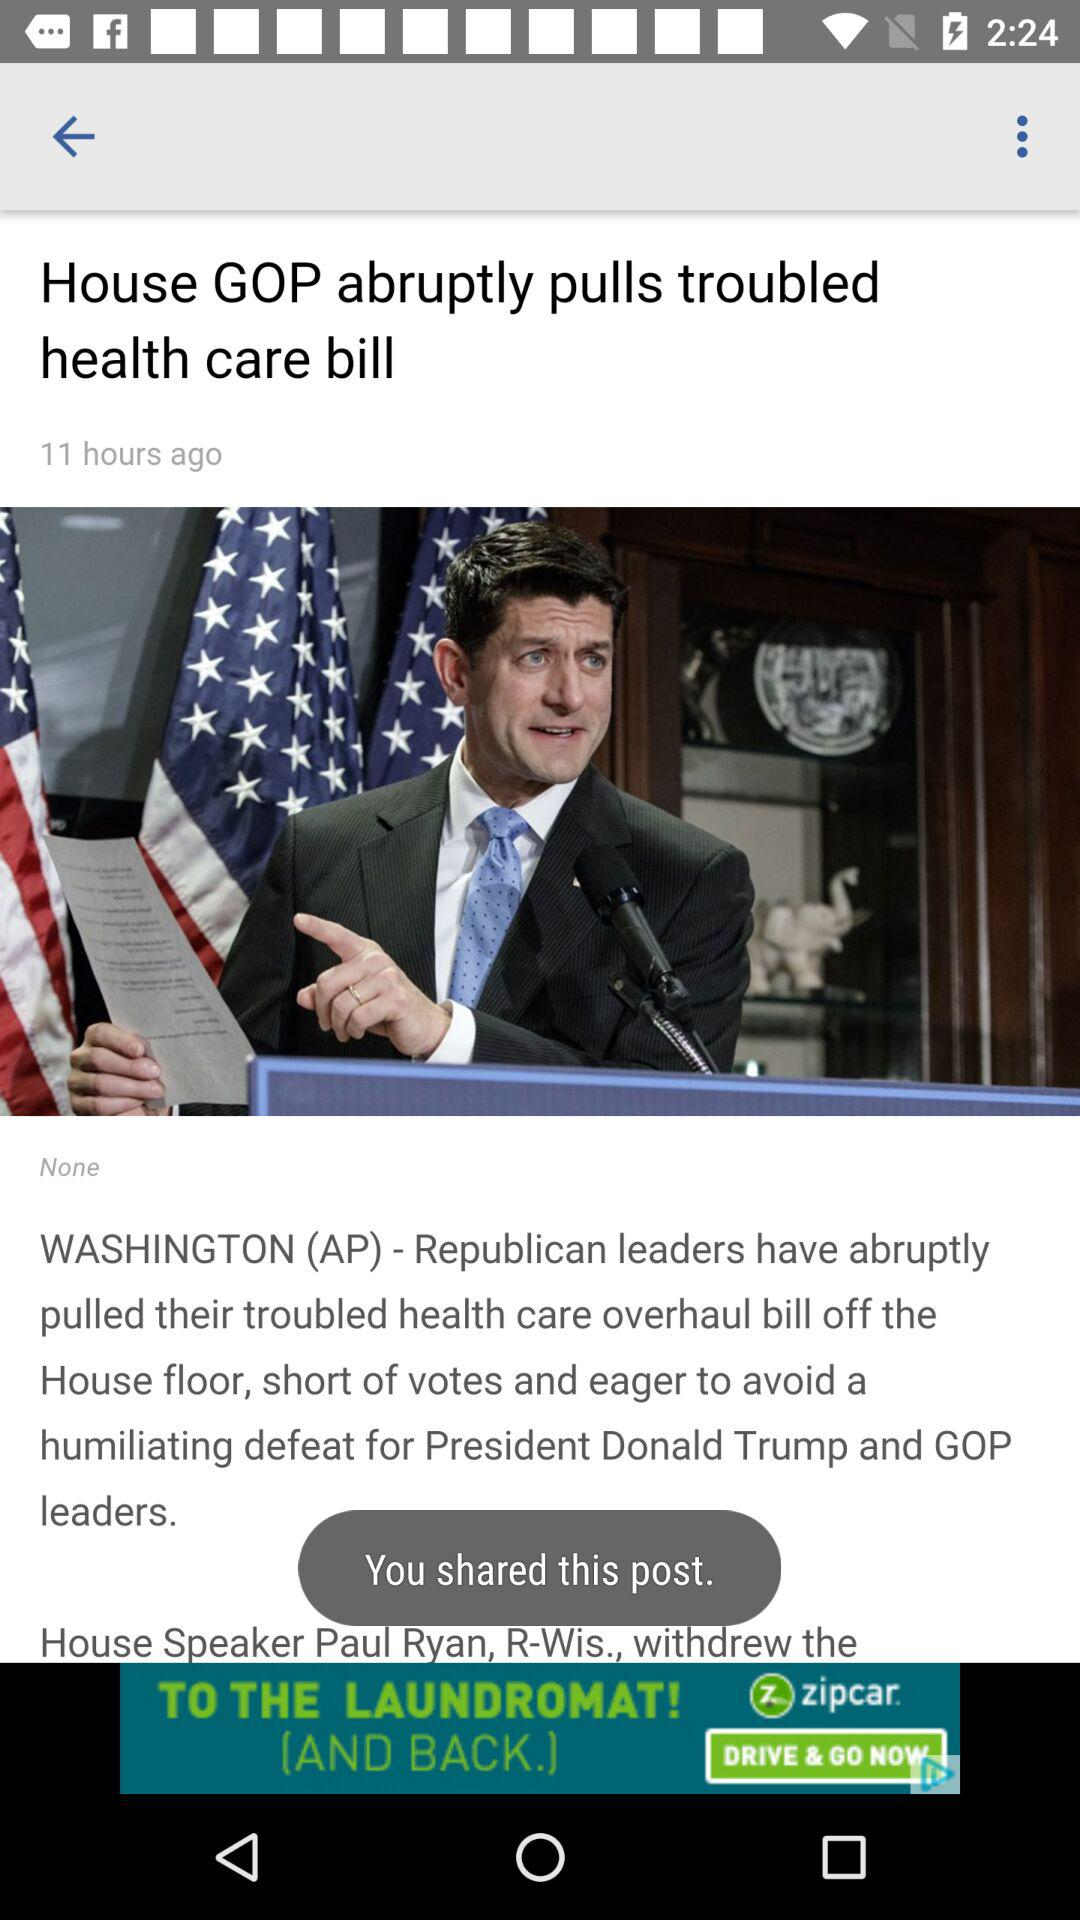How long has it been since the news was posted? It has been 11 hours since the news was posted. 